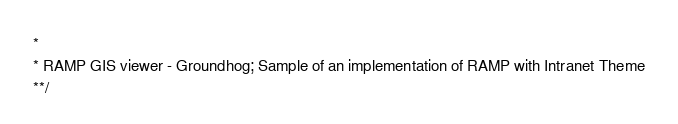Convert code to text. <code><loc_0><loc_0><loc_500><loc_500><_JavaScript_> * 
 * RAMP GIS viewer - Groundhog; Sample of an implementation of RAMP with Intranet Theme 
 **/</code> 